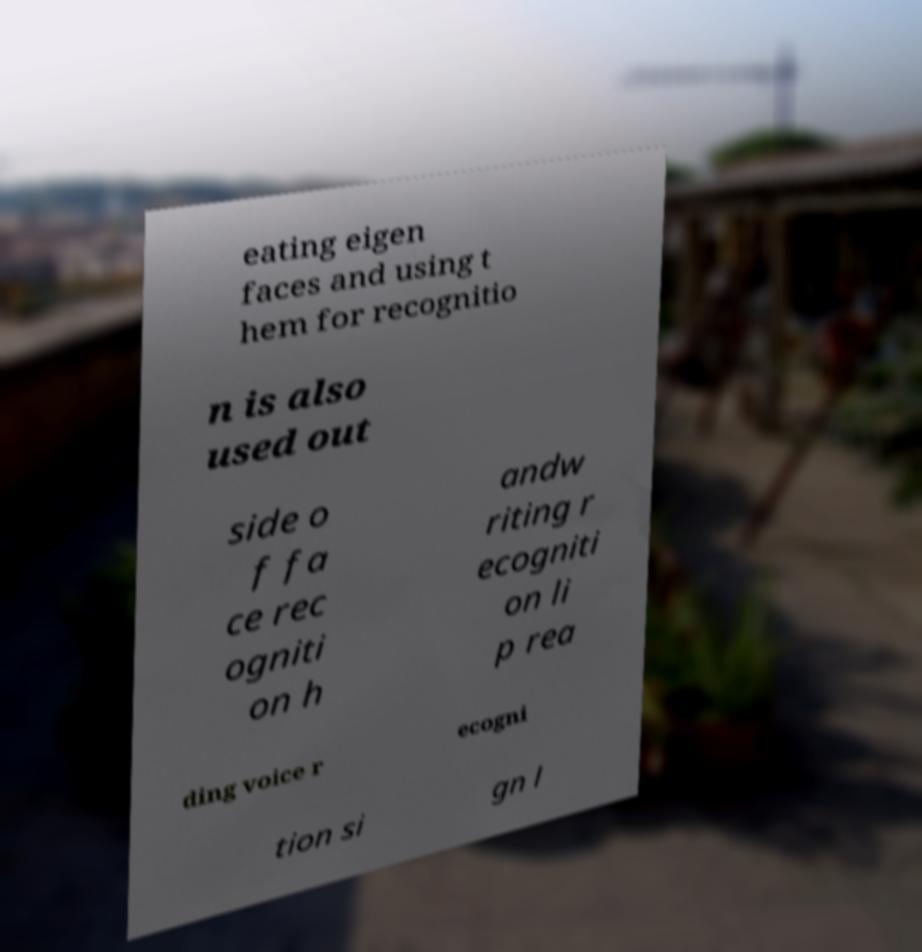Could you extract and type out the text from this image? eating eigen faces and using t hem for recognitio n is also used out side o f fa ce rec ogniti on h andw riting r ecogniti on li p rea ding voice r ecogni tion si gn l 